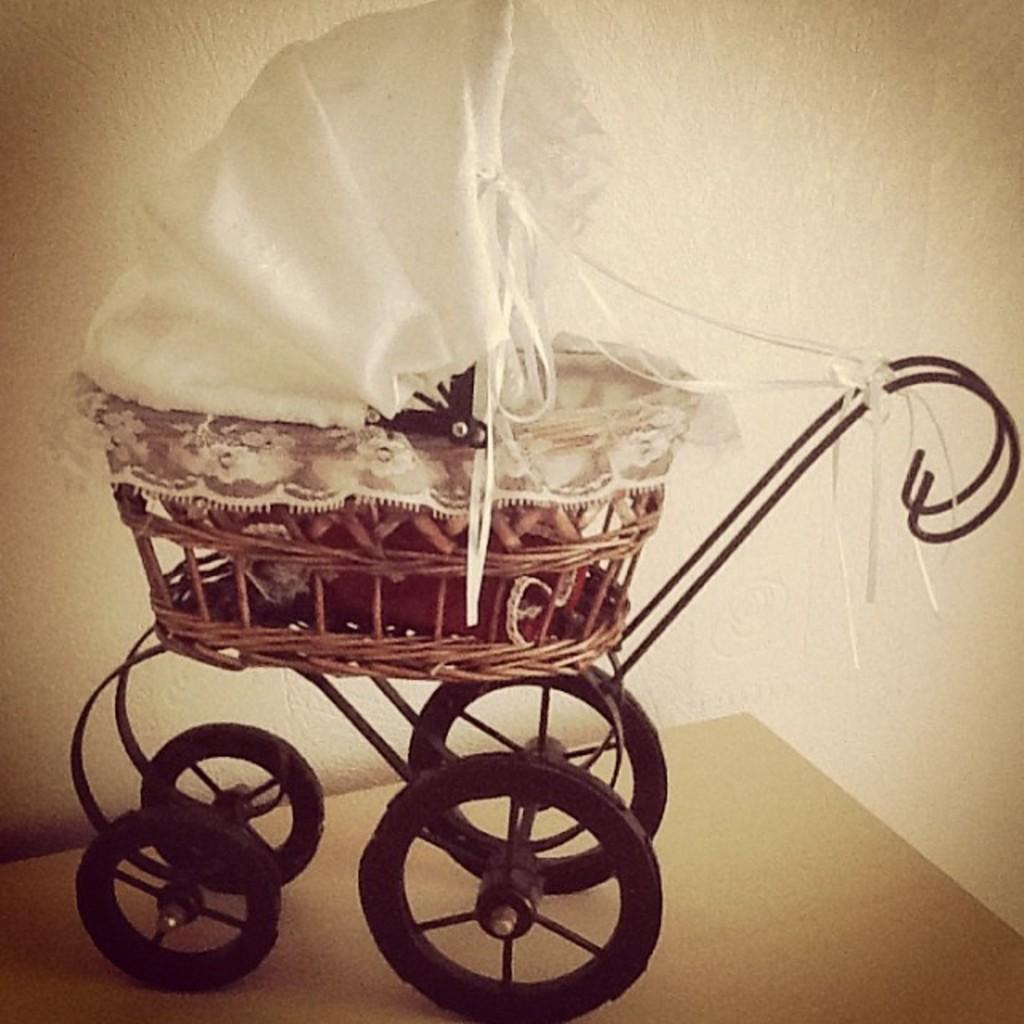What object is the main focus of the image? The main focus of the image is a baby stroller. Where is the baby stroller located in the image? The baby stroller is placed on a table in the image. What type of bean is being used to support the baby stroller in the image? There is no bean present in the image; the baby stroller is placed on a table. What system is responsible for the baby stroller's movement in the image? The image does not depict the baby stroller in motion, so there is no system responsible for its movement. 